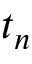Convert formula to latex. <formula><loc_0><loc_0><loc_500><loc_500>t _ { n }</formula> 